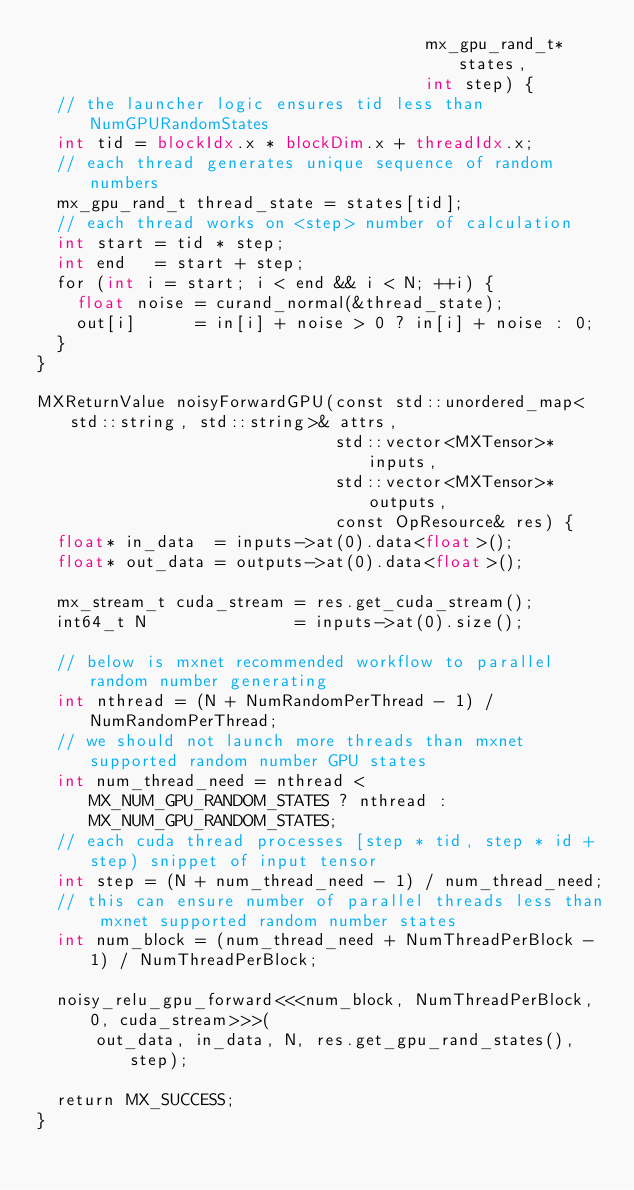<code> <loc_0><loc_0><loc_500><loc_500><_Cuda_>                                       mx_gpu_rand_t* states,
                                       int step) {
  // the launcher logic ensures tid less than NumGPURandomStates
  int tid = blockIdx.x * blockDim.x + threadIdx.x;
  // each thread generates unique sequence of random numbers
  mx_gpu_rand_t thread_state = states[tid];
  // each thread works on <step> number of calculation
  int start = tid * step;
  int end   = start + step;
  for (int i = start; i < end && i < N; ++i) {
    float noise = curand_normal(&thread_state);
    out[i]      = in[i] + noise > 0 ? in[i] + noise : 0;
  }
}

MXReturnValue noisyForwardGPU(const std::unordered_map<std::string, std::string>& attrs,
                              std::vector<MXTensor>* inputs,
                              std::vector<MXTensor>* outputs,
                              const OpResource& res) {
  float* in_data  = inputs->at(0).data<float>();
  float* out_data = outputs->at(0).data<float>();

  mx_stream_t cuda_stream = res.get_cuda_stream();
  int64_t N               = inputs->at(0).size();

  // below is mxnet recommended workflow to parallel random number generating
  int nthread = (N + NumRandomPerThread - 1) / NumRandomPerThread;
  // we should not launch more threads than mxnet supported random number GPU states
  int num_thread_need = nthread < MX_NUM_GPU_RANDOM_STATES ? nthread : MX_NUM_GPU_RANDOM_STATES;
  // each cuda thread processes [step * tid, step * id + step) snippet of input tensor
  int step = (N + num_thread_need - 1) / num_thread_need;
  // this can ensure number of parallel threads less than mxnet supported random number states
  int num_block = (num_thread_need + NumThreadPerBlock - 1) / NumThreadPerBlock;

  noisy_relu_gpu_forward<<<num_block, NumThreadPerBlock, 0, cuda_stream>>>(
      out_data, in_data, N, res.get_gpu_rand_states(), step);

  return MX_SUCCESS;
}
</code> 